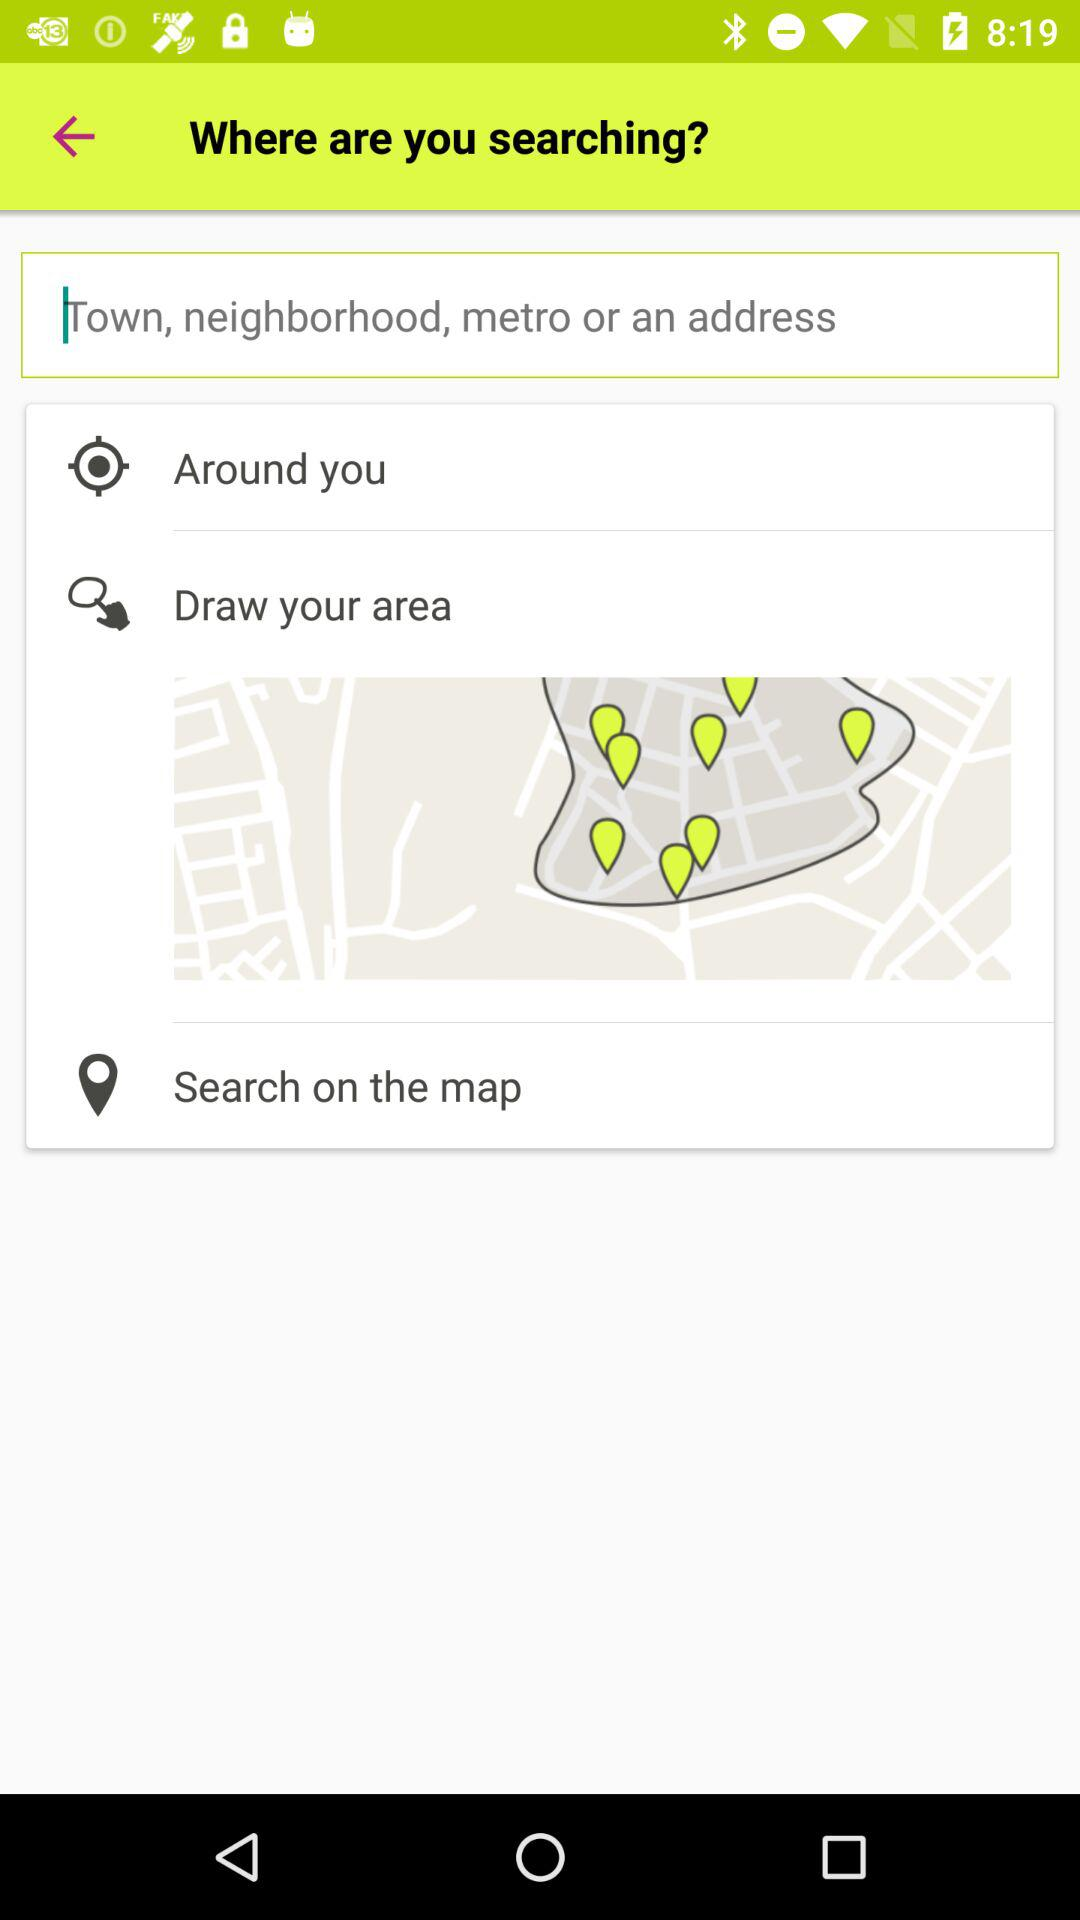How many options are there to search for a location?
Answer the question using a single word or phrase. 4 